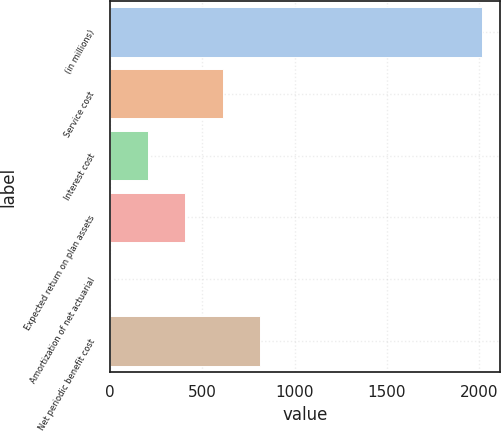Convert chart to OTSL. <chart><loc_0><loc_0><loc_500><loc_500><bar_chart><fcel>(in millions)<fcel>Service cost<fcel>Interest cost<fcel>Expected return on plan assets<fcel>Amortization of net actuarial<fcel>Net periodic benefit cost<nl><fcel>2013<fcel>609.5<fcel>208.5<fcel>409<fcel>8<fcel>810<nl></chart> 